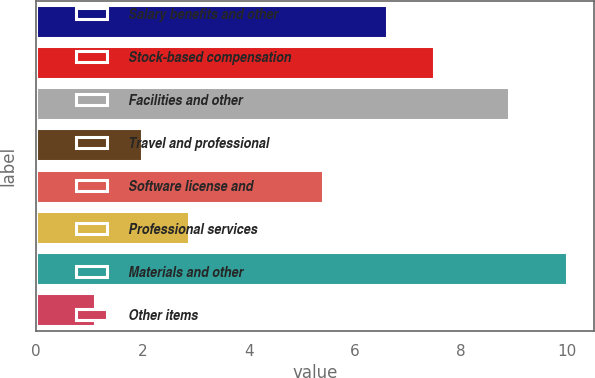<chart> <loc_0><loc_0><loc_500><loc_500><bar_chart><fcel>Salary benefits and other<fcel>Stock-based compensation<fcel>Facilities and other<fcel>Travel and professional<fcel>Software license and<fcel>Professional services<fcel>Materials and other<fcel>Other items<nl><fcel>6.6<fcel>7.49<fcel>8.9<fcel>1.99<fcel>5.4<fcel>2.88<fcel>10<fcel>1.1<nl></chart> 